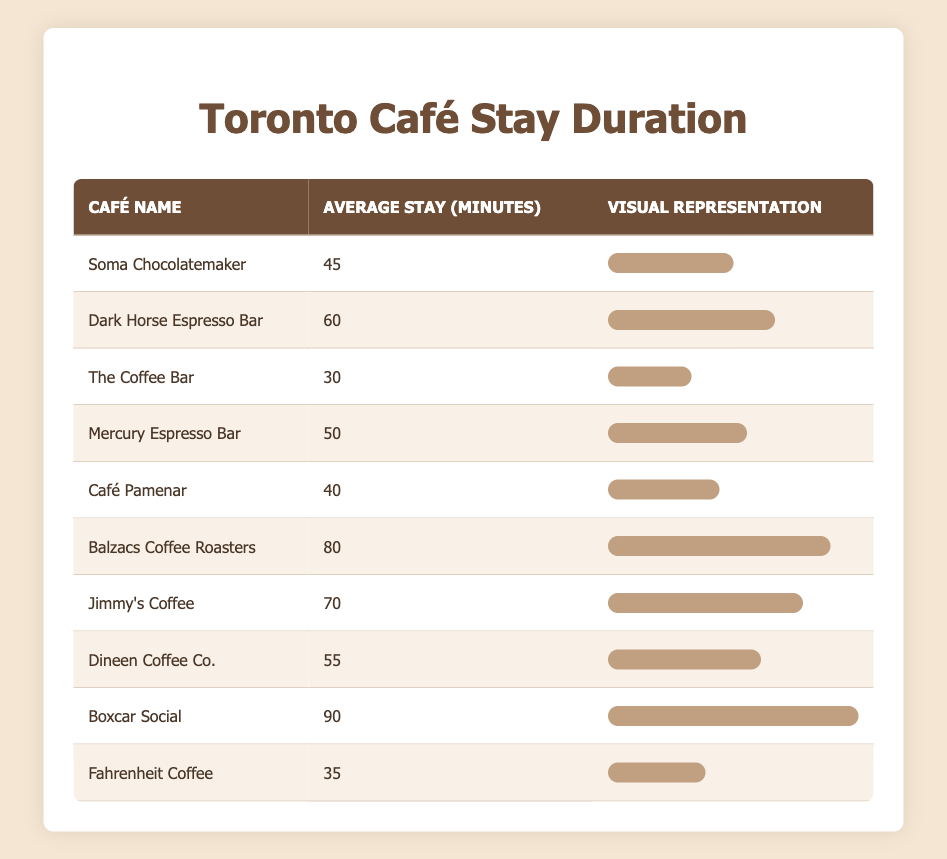What is the average stay duration at "Soma Chocolatemaker"? The table indicates that the average stay duration at "Soma Chocolatemaker" is 45 minutes.
Answer: 45 minutes Which café has the longest average stay duration? By inspecting the table, "Boxcar Social" has the longest average stay duration of 90 minutes, which is more than any other café listed.
Answer: Boxcar Social Is the average stay duration at "Fahrenheit Coffee" more than 30 minutes? The table shows that "Fahrenheit Coffee" has an average stay duration of 35 minutes, which is greater than 30 minutes. Therefore, it is true.
Answer: Yes How many cafés have an average stay duration of over 60 minutes? From the table, the cafés with an average stay duration over 60 minutes are "Balzacs Coffee Roasters" at 80 minutes, "Jimmy's Coffee" at 70 minutes, and "Boxcar Social" at 90 minutes. In total, there are three such cafés.
Answer: 3 What is the difference between the longest and shortest average stay durations? The longest stay duration in the table is 90 minutes (Boxcar Social) and the shortest is 30 minutes (The Coffee Bar). Therefore, the difference is 90 - 30 = 60 minutes.
Answer: 60 minutes Find the average of the average stay durations of all cafés. To find the average of the average stay durations, we first sum all the durations: 45 + 60 + 30 + 50 + 40 + 80 + 70 + 55 + 90 + 35 = 510 minutes. There are 10 cafés, so the average is 510/10 = 51 minutes.
Answer: 51 minutes Does "Café Pamenar" have an average stay duration that is equal to 40 minutes? The table explicitly lists "Café Pamenar" with an average stay duration of 40 minutes, confirming that this statement is true.
Answer: Yes Which café has a shorter average stay duration: "Dineen Coffee Co." or "Mercury Espresso Bar"? Referring to the table, "Dineen Coffee Co." stays an average of 55 minutes while "Mercury Espresso Bar" stays an average of 50 minutes. Since 50 minutes is less than 55 minutes, "Mercury Espresso Bar" has the shorter stay.
Answer: Mercury Espresso Bar 